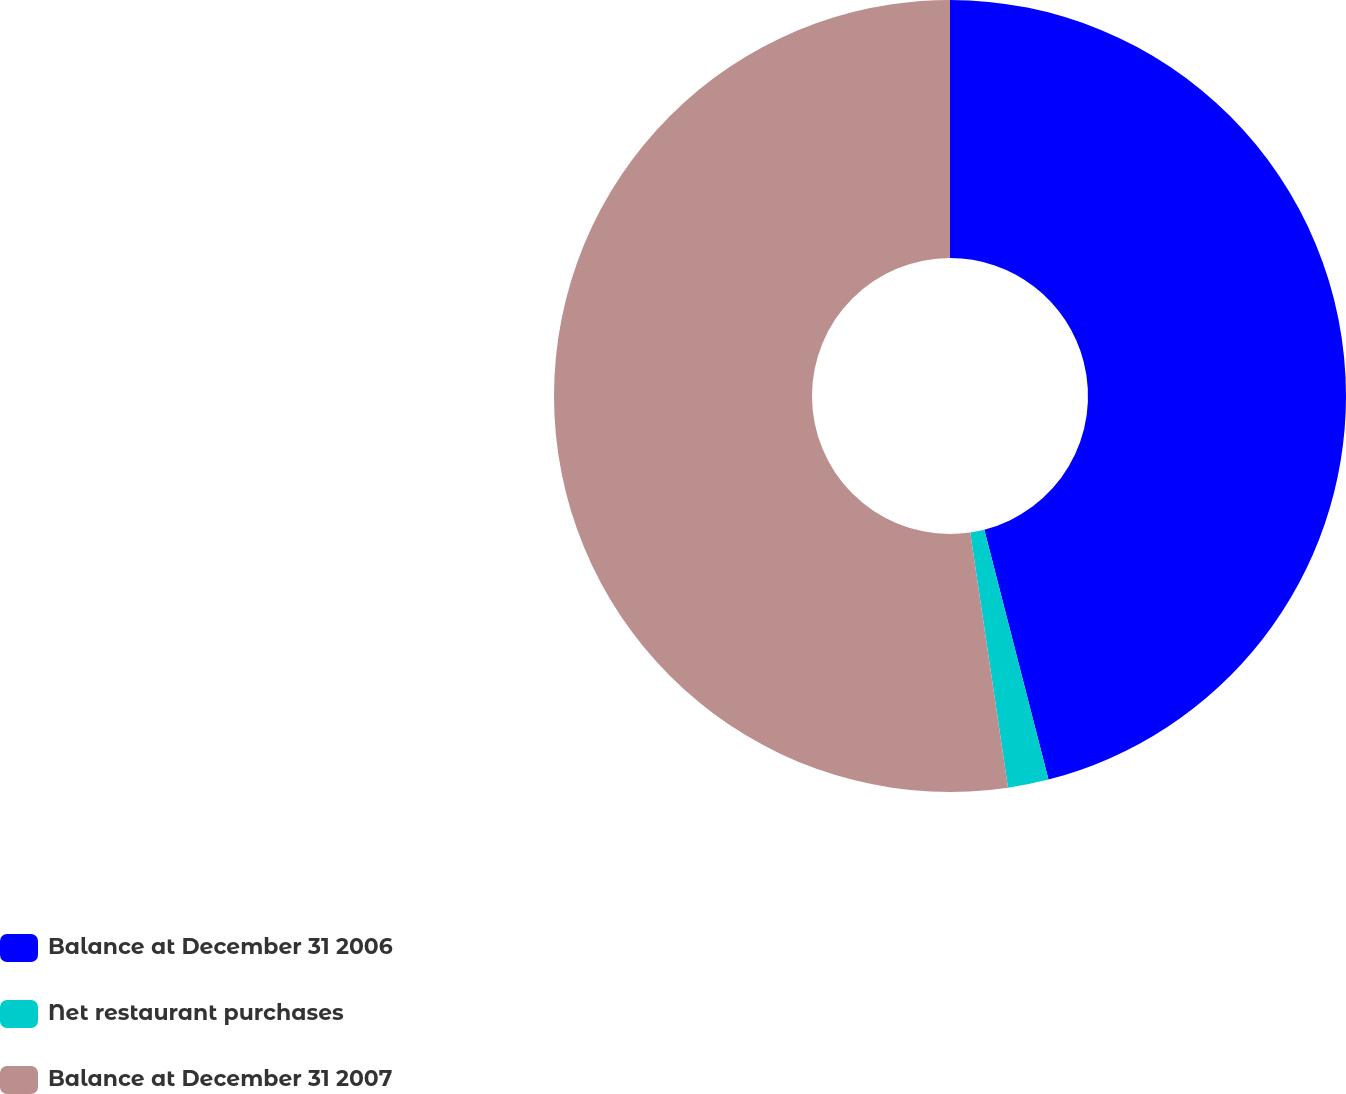<chart> <loc_0><loc_0><loc_500><loc_500><pie_chart><fcel>Balance at December 31 2006<fcel>Net restaurant purchases<fcel>Balance at December 31 2007<nl><fcel>46.0%<fcel>1.66%<fcel>52.34%<nl></chart> 